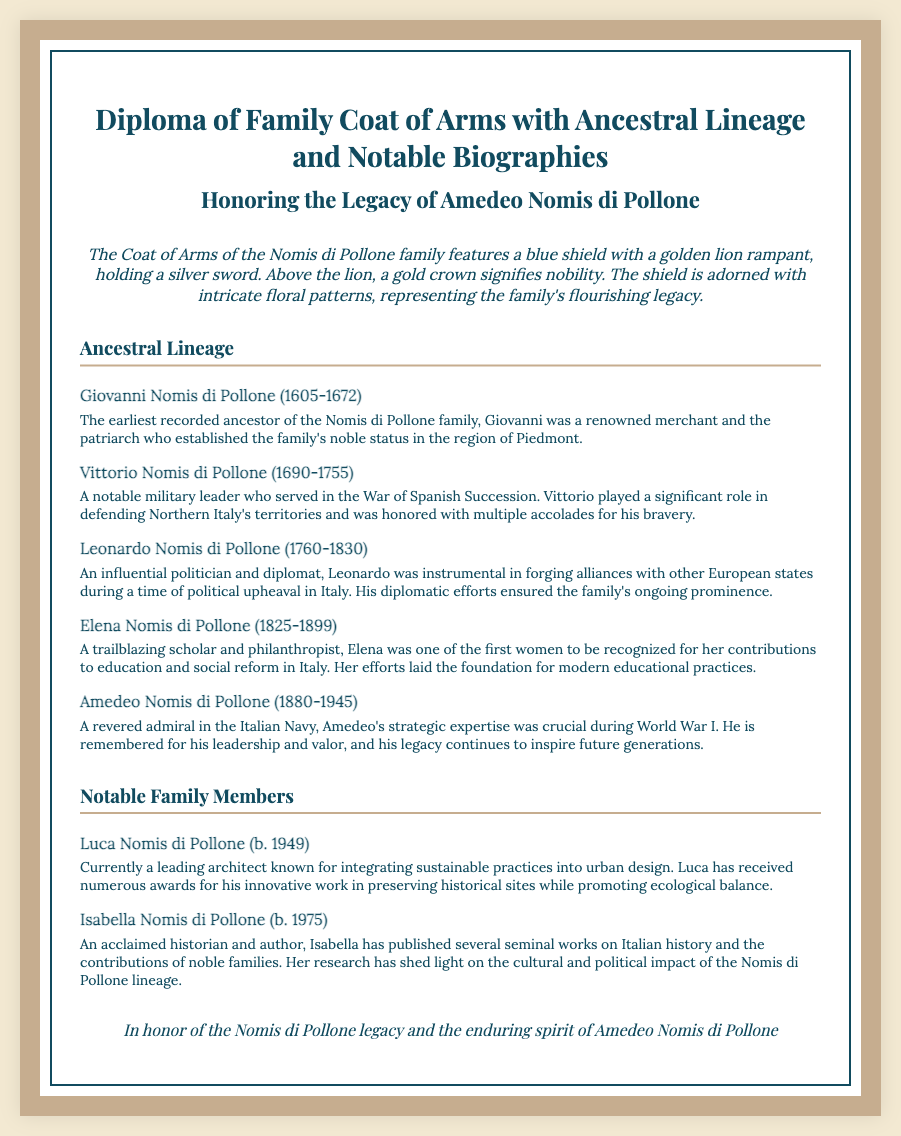What is the family name associated with the coat of arms? The document mentions the family name "Nomis di Pollone" throughout, as it honors their legacy.
Answer: Nomis di Pollone Who was the earliest recorded ancestor of the family? The document cites Giovanni Nomis di Pollone as the earliest recorded ancestor, establishing the family's noble status.
Answer: Giovanni Nomis di Pollone What year did Amedeo Nomis di Pollone pass away? The document specifies Amedeo's death year as 1945.
Answer: 1945 Which family member was a trailblazing scholar and philanthropist? The document describes Elena Nomis di Pollone as a scholar and philanthropist who significantly contributed to education and social reform.
Answer: Elena Nomis di Pollone Who is known for integrating sustainable practices into urban design? Luca Nomis di Pollone is recognized for his leading work in sustainable architecture and urban design, as mentioned in the document.
Answer: Luca Nomis di Pollone What role did Vittorio Nomis di Pollone serve in the War of Spanish Succession? The document describes Vittorio as a notable military leader with significant contributions during the war.
Answer: Military leader How many notable family members are mentioned in the document? There are three notable family members explicitly listed in the document: Luca, Isabella, and Amedeo.
Answer: Three What symbols are featured on the coat of arms? The coat of arms includes a blue shield, a golden lion rampant, a silver sword, and a gold crown, as detailed in the description.
Answer: Blue shield, golden lion, silver sword, gold crown Which family member was instrumental in forging alliances with other European states? Leonardo Nomis di Pollone is highlighted for his political efforts during his time as a politician and diplomat in the document.
Answer: Leonardo Nomis di Pollone 